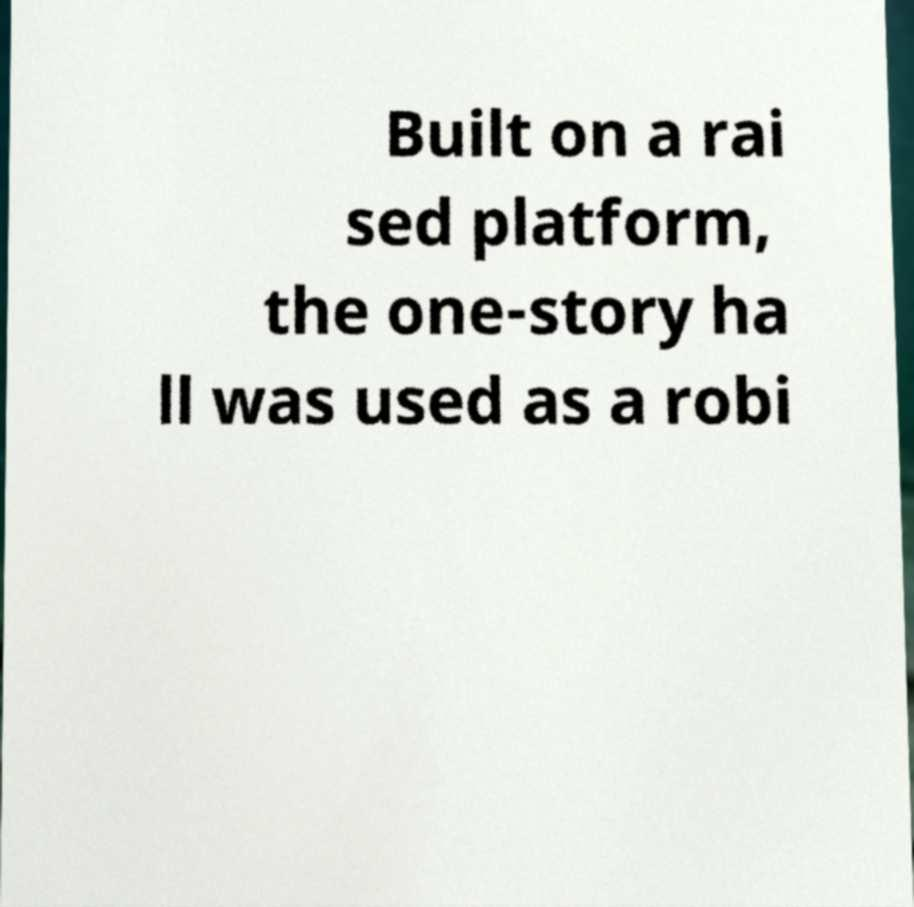Please identify and transcribe the text found in this image. Built on a rai sed platform, the one-story ha ll was used as a robi 